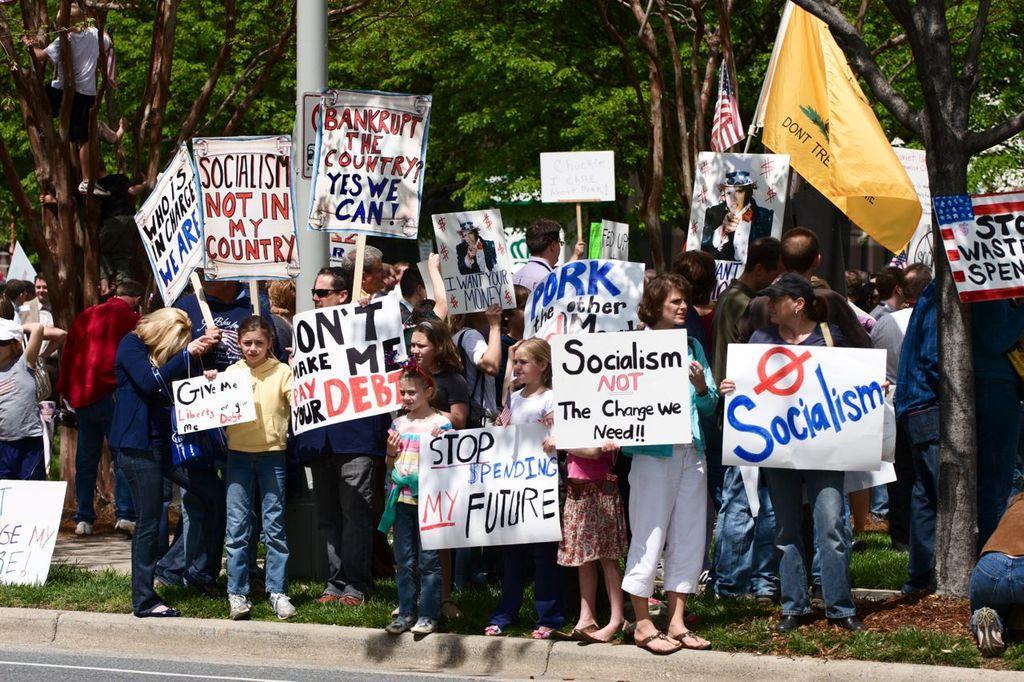Can you describe this image briefly? In this image we can see a few people, among them, some are holding the placards with some text and images, there are some trees, flags and grass, also we can see a pole. 